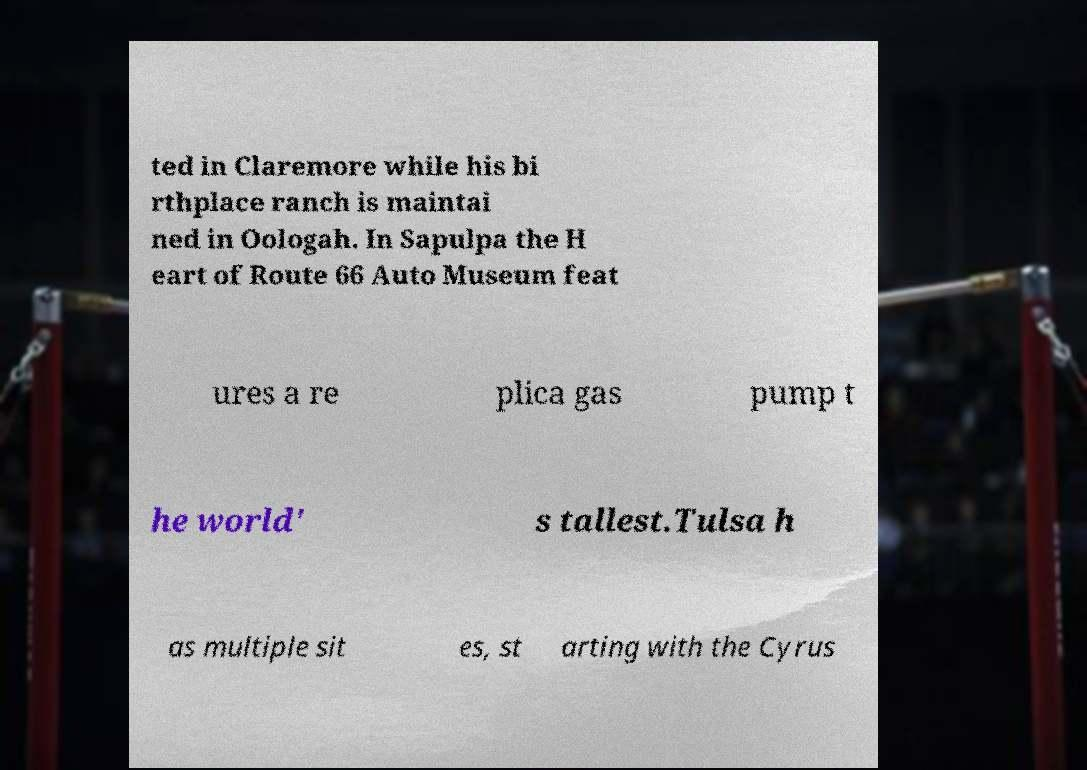I need the written content from this picture converted into text. Can you do that? ted in Claremore while his bi rthplace ranch is maintai ned in Oologah. In Sapulpa the H eart of Route 66 Auto Museum feat ures a re plica gas pump t he world' s tallest.Tulsa h as multiple sit es, st arting with the Cyrus 